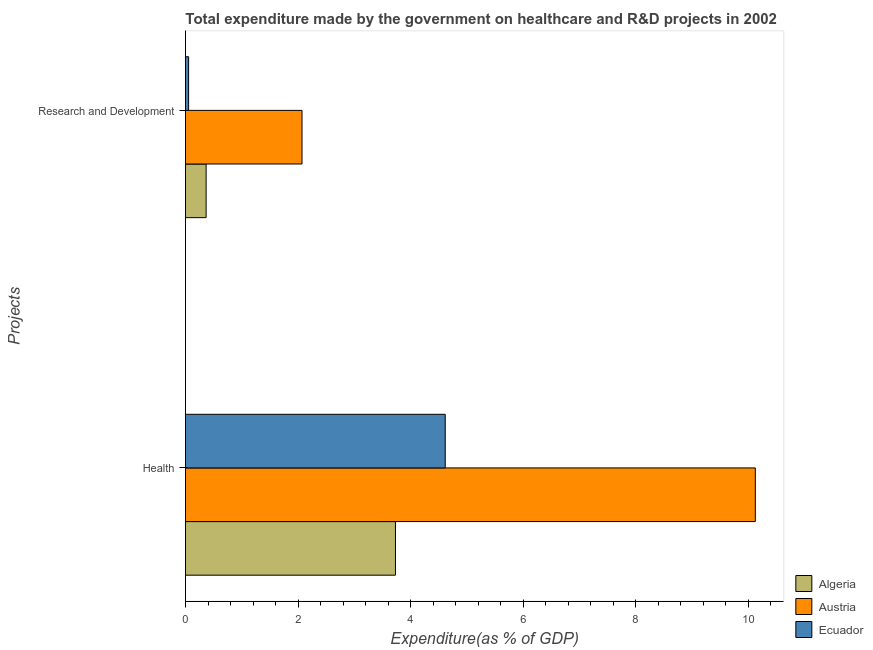How many different coloured bars are there?
Your answer should be compact. 3. How many bars are there on the 2nd tick from the top?
Your answer should be compact. 3. How many bars are there on the 2nd tick from the bottom?
Your answer should be compact. 3. What is the label of the 2nd group of bars from the top?
Provide a succinct answer. Health. What is the expenditure in healthcare in Algeria?
Provide a succinct answer. 3.73. Across all countries, what is the maximum expenditure in r&d?
Offer a very short reply. 2.07. Across all countries, what is the minimum expenditure in r&d?
Offer a very short reply. 0.06. In which country was the expenditure in r&d minimum?
Offer a terse response. Ecuador. What is the total expenditure in r&d in the graph?
Make the answer very short. 2.49. What is the difference between the expenditure in healthcare in Ecuador and that in Algeria?
Give a very brief answer. 0.88. What is the difference between the expenditure in healthcare in Ecuador and the expenditure in r&d in Algeria?
Offer a very short reply. 4.25. What is the average expenditure in r&d per country?
Give a very brief answer. 0.83. What is the difference between the expenditure in healthcare and expenditure in r&d in Ecuador?
Ensure brevity in your answer.  4.56. What is the ratio of the expenditure in r&d in Austria to that in Algeria?
Your answer should be very brief. 5.65. In how many countries, is the expenditure in healthcare greater than the average expenditure in healthcare taken over all countries?
Your answer should be compact. 1. What does the 1st bar from the top in Research and Development represents?
Make the answer very short. Ecuador. What does the 3rd bar from the bottom in Health represents?
Offer a very short reply. Ecuador. Are all the bars in the graph horizontal?
Your answer should be very brief. Yes. How many countries are there in the graph?
Offer a terse response. 3. Are the values on the major ticks of X-axis written in scientific E-notation?
Keep it short and to the point. No. Does the graph contain any zero values?
Ensure brevity in your answer.  No. Does the graph contain grids?
Ensure brevity in your answer.  No. Where does the legend appear in the graph?
Keep it short and to the point. Bottom right. How many legend labels are there?
Give a very brief answer. 3. How are the legend labels stacked?
Provide a succinct answer. Vertical. What is the title of the graph?
Your answer should be compact. Total expenditure made by the government on healthcare and R&D projects in 2002. Does "French Polynesia" appear as one of the legend labels in the graph?
Your answer should be very brief. No. What is the label or title of the X-axis?
Your answer should be very brief. Expenditure(as % of GDP). What is the label or title of the Y-axis?
Your answer should be compact. Projects. What is the Expenditure(as % of GDP) in Algeria in Health?
Your answer should be compact. 3.73. What is the Expenditure(as % of GDP) in Austria in Health?
Make the answer very short. 10.12. What is the Expenditure(as % of GDP) in Ecuador in Health?
Your response must be concise. 4.61. What is the Expenditure(as % of GDP) in Algeria in Research and Development?
Your answer should be very brief. 0.37. What is the Expenditure(as % of GDP) in Austria in Research and Development?
Your answer should be very brief. 2.07. What is the Expenditure(as % of GDP) in Ecuador in Research and Development?
Ensure brevity in your answer.  0.06. Across all Projects, what is the maximum Expenditure(as % of GDP) in Algeria?
Your answer should be compact. 3.73. Across all Projects, what is the maximum Expenditure(as % of GDP) in Austria?
Provide a short and direct response. 10.12. Across all Projects, what is the maximum Expenditure(as % of GDP) of Ecuador?
Ensure brevity in your answer.  4.61. Across all Projects, what is the minimum Expenditure(as % of GDP) of Algeria?
Your response must be concise. 0.37. Across all Projects, what is the minimum Expenditure(as % of GDP) in Austria?
Give a very brief answer. 2.07. Across all Projects, what is the minimum Expenditure(as % of GDP) in Ecuador?
Provide a short and direct response. 0.06. What is the total Expenditure(as % of GDP) of Algeria in the graph?
Your response must be concise. 4.1. What is the total Expenditure(as % of GDP) of Austria in the graph?
Offer a very short reply. 12.19. What is the total Expenditure(as % of GDP) in Ecuador in the graph?
Keep it short and to the point. 4.67. What is the difference between the Expenditure(as % of GDP) in Algeria in Health and that in Research and Development?
Ensure brevity in your answer.  3.36. What is the difference between the Expenditure(as % of GDP) of Austria in Health and that in Research and Development?
Offer a very short reply. 8.05. What is the difference between the Expenditure(as % of GDP) in Ecuador in Health and that in Research and Development?
Make the answer very short. 4.56. What is the difference between the Expenditure(as % of GDP) of Algeria in Health and the Expenditure(as % of GDP) of Austria in Research and Development?
Your answer should be very brief. 1.66. What is the difference between the Expenditure(as % of GDP) of Algeria in Health and the Expenditure(as % of GDP) of Ecuador in Research and Development?
Offer a terse response. 3.67. What is the difference between the Expenditure(as % of GDP) in Austria in Health and the Expenditure(as % of GDP) in Ecuador in Research and Development?
Make the answer very short. 10.07. What is the average Expenditure(as % of GDP) in Algeria per Projects?
Ensure brevity in your answer.  2.05. What is the average Expenditure(as % of GDP) of Austria per Projects?
Give a very brief answer. 6.1. What is the average Expenditure(as % of GDP) in Ecuador per Projects?
Your answer should be very brief. 2.33. What is the difference between the Expenditure(as % of GDP) of Algeria and Expenditure(as % of GDP) of Austria in Health?
Ensure brevity in your answer.  -6.39. What is the difference between the Expenditure(as % of GDP) of Algeria and Expenditure(as % of GDP) of Ecuador in Health?
Give a very brief answer. -0.88. What is the difference between the Expenditure(as % of GDP) of Austria and Expenditure(as % of GDP) of Ecuador in Health?
Your answer should be very brief. 5.51. What is the difference between the Expenditure(as % of GDP) of Algeria and Expenditure(as % of GDP) of Austria in Research and Development?
Provide a short and direct response. -1.7. What is the difference between the Expenditure(as % of GDP) of Algeria and Expenditure(as % of GDP) of Ecuador in Research and Development?
Your response must be concise. 0.31. What is the difference between the Expenditure(as % of GDP) in Austria and Expenditure(as % of GDP) in Ecuador in Research and Development?
Give a very brief answer. 2.01. What is the ratio of the Expenditure(as % of GDP) in Algeria in Health to that in Research and Development?
Provide a short and direct response. 10.18. What is the ratio of the Expenditure(as % of GDP) in Austria in Health to that in Research and Development?
Ensure brevity in your answer.  4.89. What is the ratio of the Expenditure(as % of GDP) in Ecuador in Health to that in Research and Development?
Offer a very short reply. 83.38. What is the difference between the highest and the second highest Expenditure(as % of GDP) of Algeria?
Ensure brevity in your answer.  3.36. What is the difference between the highest and the second highest Expenditure(as % of GDP) of Austria?
Give a very brief answer. 8.05. What is the difference between the highest and the second highest Expenditure(as % of GDP) in Ecuador?
Ensure brevity in your answer.  4.56. What is the difference between the highest and the lowest Expenditure(as % of GDP) of Algeria?
Your response must be concise. 3.36. What is the difference between the highest and the lowest Expenditure(as % of GDP) of Austria?
Offer a terse response. 8.05. What is the difference between the highest and the lowest Expenditure(as % of GDP) in Ecuador?
Provide a succinct answer. 4.56. 